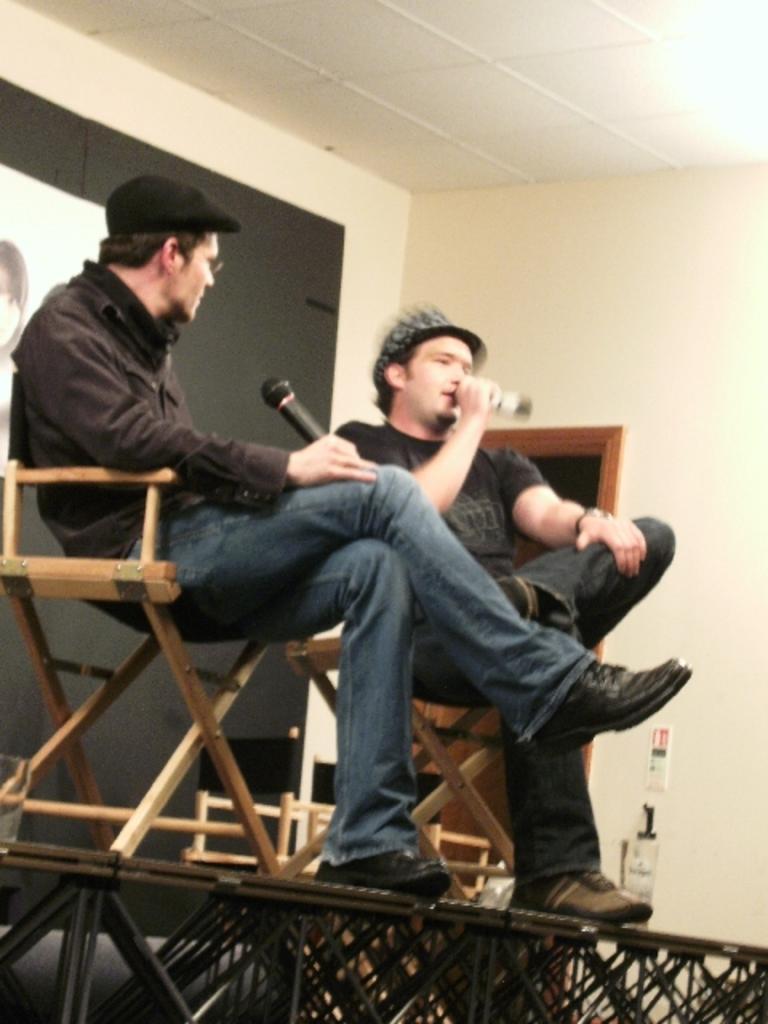Could you give a brief overview of what you see in this image? This image is taken indoors. In the background there is a wall with a door and there is a picture frame on it. At the bottom of the image there is a dais. In the middle of the image two men are sitting on the chairs and they are holding mics in their hands. 